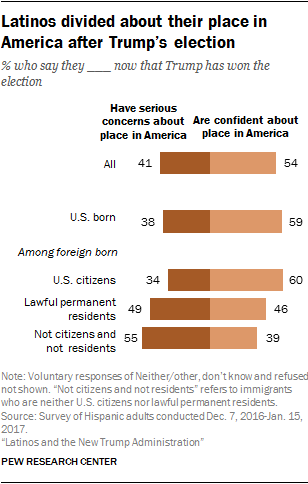What can we infer about the Latino population's feelings towards their place in America post-election? The image, a chart from Pew Research Center, suggests a polarized sentiment within the Latino community after Trump's election. While a significant portion expresses confidence about their place in America, there is also a notable percentage that has serious concerns, reflecting division in their outlook. 